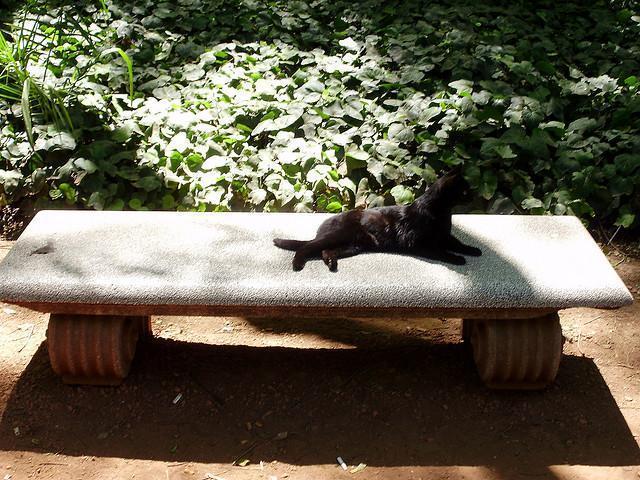How many buses are behind a street sign?
Give a very brief answer. 0. 